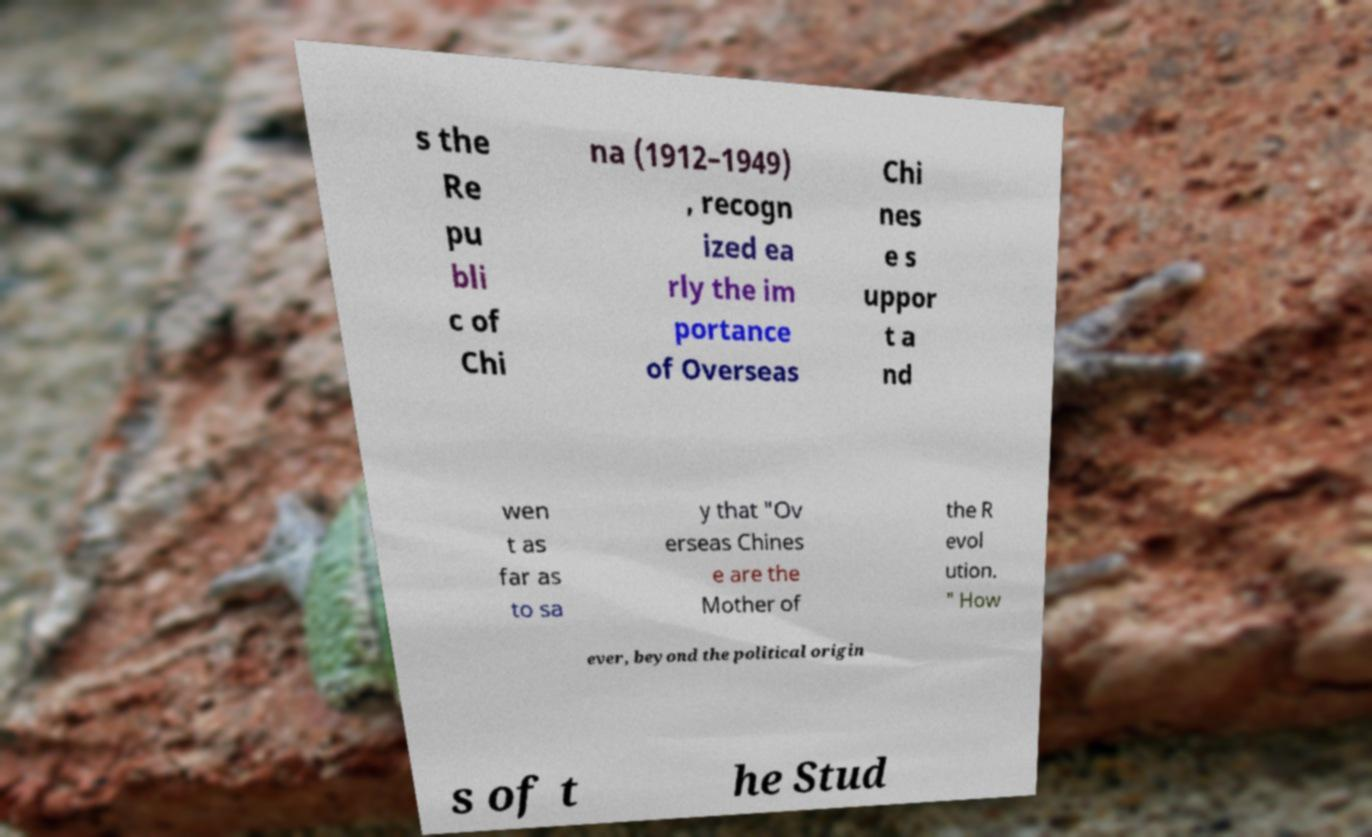There's text embedded in this image that I need extracted. Can you transcribe it verbatim? s the Re pu bli c of Chi na (1912–1949) , recogn ized ea rly the im portance of Overseas Chi nes e s uppor t a nd wen t as far as to sa y that "Ov erseas Chines e are the Mother of the R evol ution. " How ever, beyond the political origin s of t he Stud 